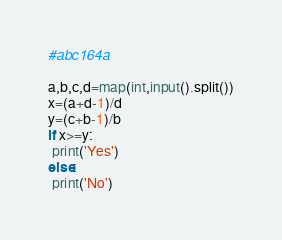<code> <loc_0><loc_0><loc_500><loc_500><_Python_>#abc164a

a,b,c,d=map(int,input().split())
x=(a+d-1)/d
y=(c+b-1)/b
if x>=y:
 print('Yes')
else:
 print('No')
</code> 